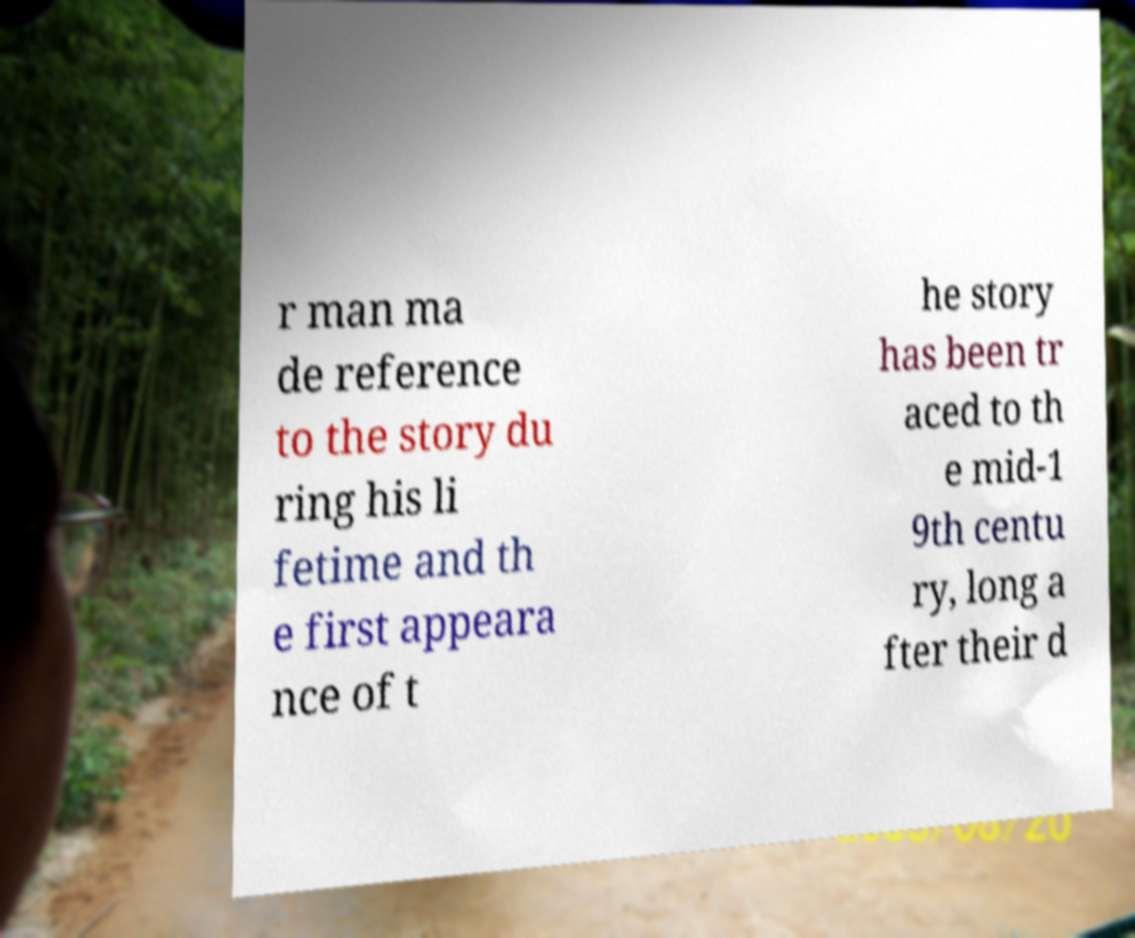Could you assist in decoding the text presented in this image and type it out clearly? r man ma de reference to the story du ring his li fetime and th e first appeara nce of t he story has been tr aced to th e mid-1 9th centu ry, long a fter their d 